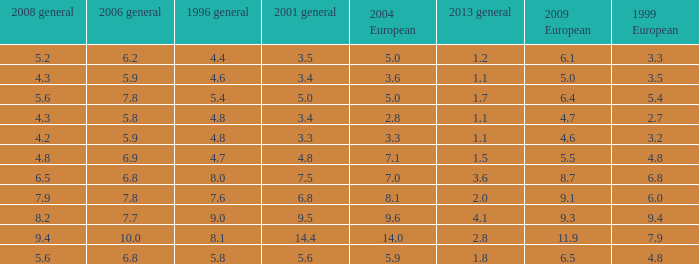How many values for 1999 European correspond to a value more than 4.7 in 2009 European, general 2001 more than 7.5, 2006 general at 10, and more than 9.4 in general 2008? 0.0. 